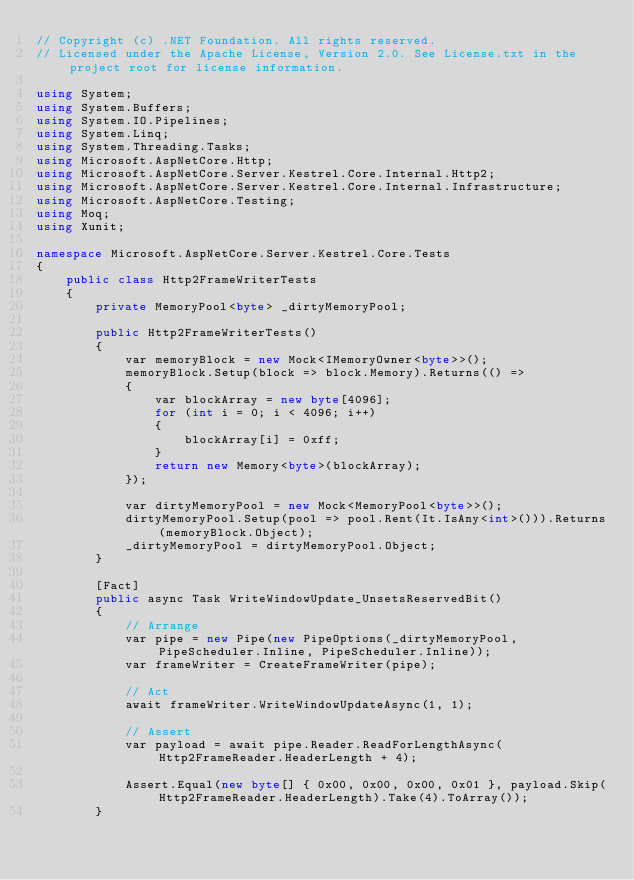Convert code to text. <code><loc_0><loc_0><loc_500><loc_500><_C#_>// Copyright (c) .NET Foundation. All rights reserved.
// Licensed under the Apache License, Version 2.0. See License.txt in the project root for license information.

using System;
using System.Buffers;
using System.IO.Pipelines;
using System.Linq;
using System.Threading.Tasks;
using Microsoft.AspNetCore.Http;
using Microsoft.AspNetCore.Server.Kestrel.Core.Internal.Http2;
using Microsoft.AspNetCore.Server.Kestrel.Core.Internal.Infrastructure;
using Microsoft.AspNetCore.Testing;
using Moq;
using Xunit;

namespace Microsoft.AspNetCore.Server.Kestrel.Core.Tests
{
    public class Http2FrameWriterTests
    {
        private MemoryPool<byte> _dirtyMemoryPool;

        public Http2FrameWriterTests()
        {
            var memoryBlock = new Mock<IMemoryOwner<byte>>();
            memoryBlock.Setup(block => block.Memory).Returns(() =>
            {
                var blockArray = new byte[4096];
                for (int i = 0; i < 4096; i++)
                {
                    blockArray[i] = 0xff;
                }
                return new Memory<byte>(blockArray);
            });

            var dirtyMemoryPool = new Mock<MemoryPool<byte>>();
            dirtyMemoryPool.Setup(pool => pool.Rent(It.IsAny<int>())).Returns(memoryBlock.Object);
            _dirtyMemoryPool = dirtyMemoryPool.Object;
        }

        [Fact]
        public async Task WriteWindowUpdate_UnsetsReservedBit()
        {
            // Arrange
            var pipe = new Pipe(new PipeOptions(_dirtyMemoryPool, PipeScheduler.Inline, PipeScheduler.Inline));
            var frameWriter = CreateFrameWriter(pipe);

            // Act
            await frameWriter.WriteWindowUpdateAsync(1, 1);

            // Assert
            var payload = await pipe.Reader.ReadForLengthAsync(Http2FrameReader.HeaderLength + 4);

            Assert.Equal(new byte[] { 0x00, 0x00, 0x00, 0x01 }, payload.Skip(Http2FrameReader.HeaderLength).Take(4).ToArray());
        }
</code> 